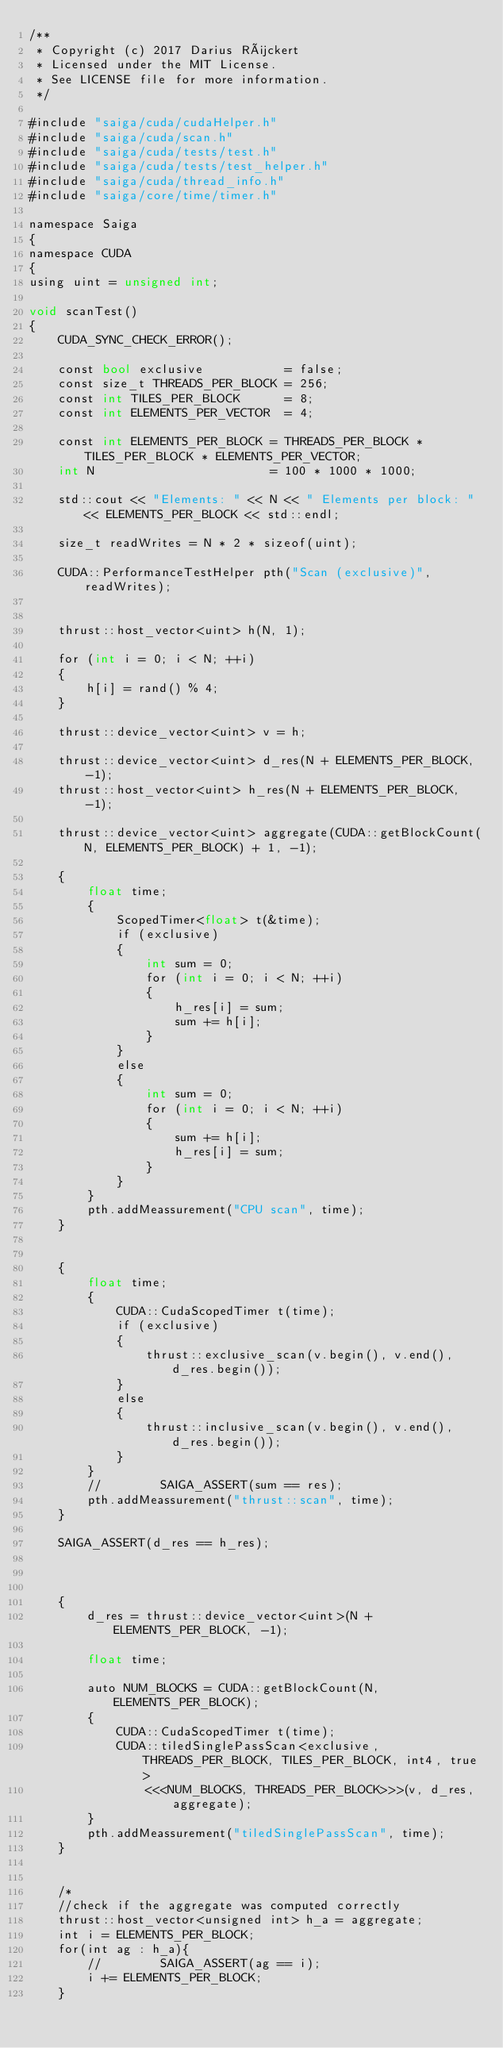<code> <loc_0><loc_0><loc_500><loc_500><_Cuda_>/**
 * Copyright (c) 2017 Darius Rückert
 * Licensed under the MIT License.
 * See LICENSE file for more information.
 */

#include "saiga/cuda/cudaHelper.h"
#include "saiga/cuda/scan.h"
#include "saiga/cuda/tests/test.h"
#include "saiga/cuda/tests/test_helper.h"
#include "saiga/cuda/thread_info.h"
#include "saiga/core/time/timer.h"

namespace Saiga
{
namespace CUDA
{
using uint = unsigned int;

void scanTest()
{
    CUDA_SYNC_CHECK_ERROR();

    const bool exclusive           = false;
    const size_t THREADS_PER_BLOCK = 256;
    const int TILES_PER_BLOCK      = 8;
    const int ELEMENTS_PER_VECTOR  = 4;

    const int ELEMENTS_PER_BLOCK = THREADS_PER_BLOCK * TILES_PER_BLOCK * ELEMENTS_PER_VECTOR;
    int N                        = 100 * 1000 * 1000;

    std::cout << "Elements: " << N << " Elements per block: " << ELEMENTS_PER_BLOCK << std::endl;

    size_t readWrites = N * 2 * sizeof(uint);

    CUDA::PerformanceTestHelper pth("Scan (exclusive)", readWrites);


    thrust::host_vector<uint> h(N, 1);

    for (int i = 0; i < N; ++i)
    {
        h[i] = rand() % 4;
    }

    thrust::device_vector<uint> v = h;

    thrust::device_vector<uint> d_res(N + ELEMENTS_PER_BLOCK, -1);
    thrust::host_vector<uint> h_res(N + ELEMENTS_PER_BLOCK, -1);

    thrust::device_vector<uint> aggregate(CUDA::getBlockCount(N, ELEMENTS_PER_BLOCK) + 1, -1);

    {
        float time;
        {
            ScopedTimer<float> t(&time);
            if (exclusive)
            {
                int sum = 0;
                for (int i = 0; i < N; ++i)
                {
                    h_res[i] = sum;
                    sum += h[i];
                }
            }
            else
            {
                int sum = 0;
                for (int i = 0; i < N; ++i)
                {
                    sum += h[i];
                    h_res[i] = sum;
                }
            }
        }
        pth.addMeassurement("CPU scan", time);
    }


    {
        float time;
        {
            CUDA::CudaScopedTimer t(time);
            if (exclusive)
            {
                thrust::exclusive_scan(v.begin(), v.end(), d_res.begin());
            }
            else
            {
                thrust::inclusive_scan(v.begin(), v.end(), d_res.begin());
            }
        }
        //        SAIGA_ASSERT(sum == res);
        pth.addMeassurement("thrust::scan", time);
    }

    SAIGA_ASSERT(d_res == h_res);



    {
        d_res = thrust::device_vector<uint>(N + ELEMENTS_PER_BLOCK, -1);

        float time;

        auto NUM_BLOCKS = CUDA::getBlockCount(N, ELEMENTS_PER_BLOCK);
        {
            CUDA::CudaScopedTimer t(time);
            CUDA::tiledSinglePassScan<exclusive, THREADS_PER_BLOCK, TILES_PER_BLOCK, int4, true>
                <<<NUM_BLOCKS, THREADS_PER_BLOCK>>>(v, d_res, aggregate);
        }
        pth.addMeassurement("tiledSinglePassScan", time);
    }


    /*
    //check if the aggregate was computed correctly
    thrust::host_vector<unsigned int> h_a = aggregate;
    int i = ELEMENTS_PER_BLOCK;
    for(int ag : h_a){
        //        SAIGA_ASSERT(ag == i);
        i += ELEMENTS_PER_BLOCK;
    }
</code> 